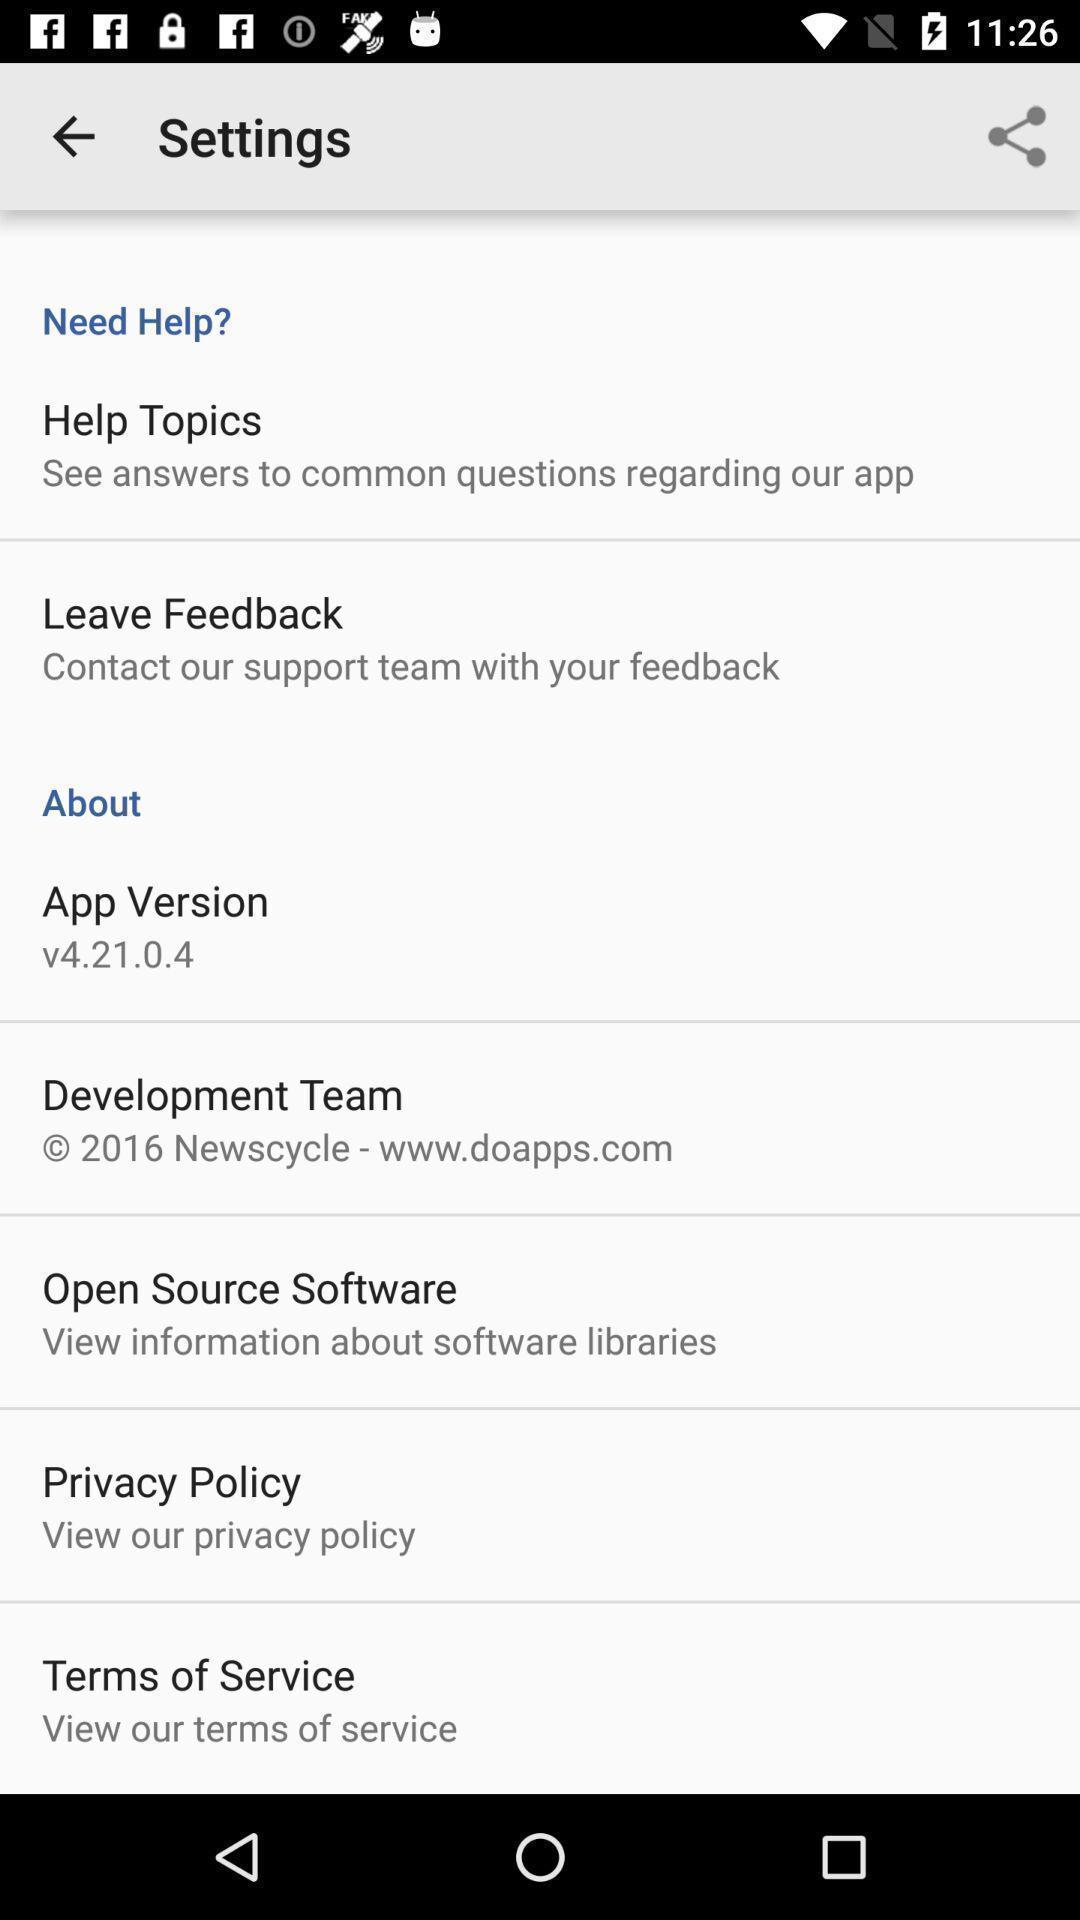Tell me about the visual elements in this screen capture. Screen showing settings page. 